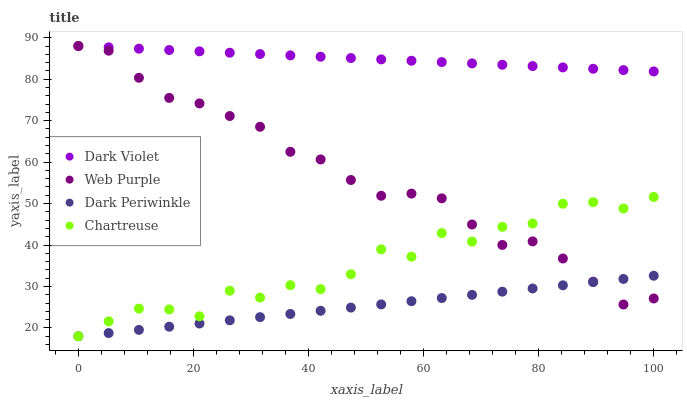Does Dark Periwinkle have the minimum area under the curve?
Answer yes or no. Yes. Does Dark Violet have the maximum area under the curve?
Answer yes or no. Yes. Does Web Purple have the minimum area under the curve?
Answer yes or no. No. Does Web Purple have the maximum area under the curve?
Answer yes or no. No. Is Dark Periwinkle the smoothest?
Answer yes or no. Yes. Is Chartreuse the roughest?
Answer yes or no. Yes. Is Web Purple the smoothest?
Answer yes or no. No. Is Web Purple the roughest?
Answer yes or no. No. Does Chartreuse have the lowest value?
Answer yes or no. Yes. Does Web Purple have the lowest value?
Answer yes or no. No. Does Dark Violet have the highest value?
Answer yes or no. Yes. Does Dark Periwinkle have the highest value?
Answer yes or no. No. Is Chartreuse less than Dark Violet?
Answer yes or no. Yes. Is Dark Violet greater than Dark Periwinkle?
Answer yes or no. Yes. Does Web Purple intersect Dark Violet?
Answer yes or no. Yes. Is Web Purple less than Dark Violet?
Answer yes or no. No. Is Web Purple greater than Dark Violet?
Answer yes or no. No. Does Chartreuse intersect Dark Violet?
Answer yes or no. No. 